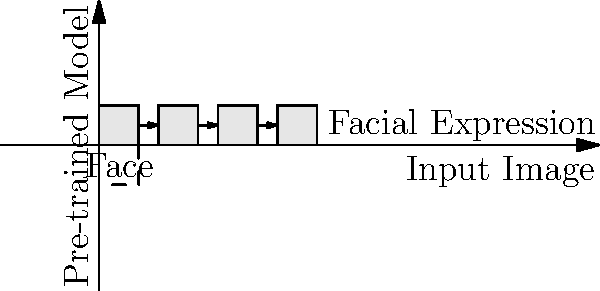In a real-time coding challenge, you're tasked with implementing facial expression recognition using a pre-trained model. Which of the following steps is NOT typically part of the process when using a pre-trained model for facial expression recognition?

A) Image preprocessing
B) Feature extraction
C) Model fine-tuning
D) Expression classification Let's break down the typical process of using a pre-trained model for facial expression recognition:

1. Image preprocessing: This step involves preparing the input image for the model. It may include resizing the image to match the model's input size, normalizing pixel values, and potentially applying face detection to crop the image to the face region.

2. Feature extraction: In a pre-trained model, this step is typically handled by the convolutional layers of the neural network. These layers have already learned to extract relevant features from facial images during the initial training process.

3. Expression classification: This is the final step where the model uses the extracted features to predict the facial expression. In a pre-trained model, this is usually done by the fully connected layers at the end of the network.

4. Model fine-tuning: This step is not typically part of the process when using a pre-trained model "as is". Fine-tuning involves further training the model on a specific dataset, which is often done when adapting a pre-trained model to a new task or dataset, but it's not necessary for using an already trained model.

When using a pre-trained model, you generally don't need to perform fine-tuning unless you're adapting the model to a new set of expressions or trying to improve its performance on a specific dataset. The pre-trained model is already capable of recognizing facial expressions based on its initial training.

Therefore, the step that is NOT typically part of the process when using a pre-trained model for facial expression recognition is model fine-tuning (option C).
Answer: C) Model fine-tuning 